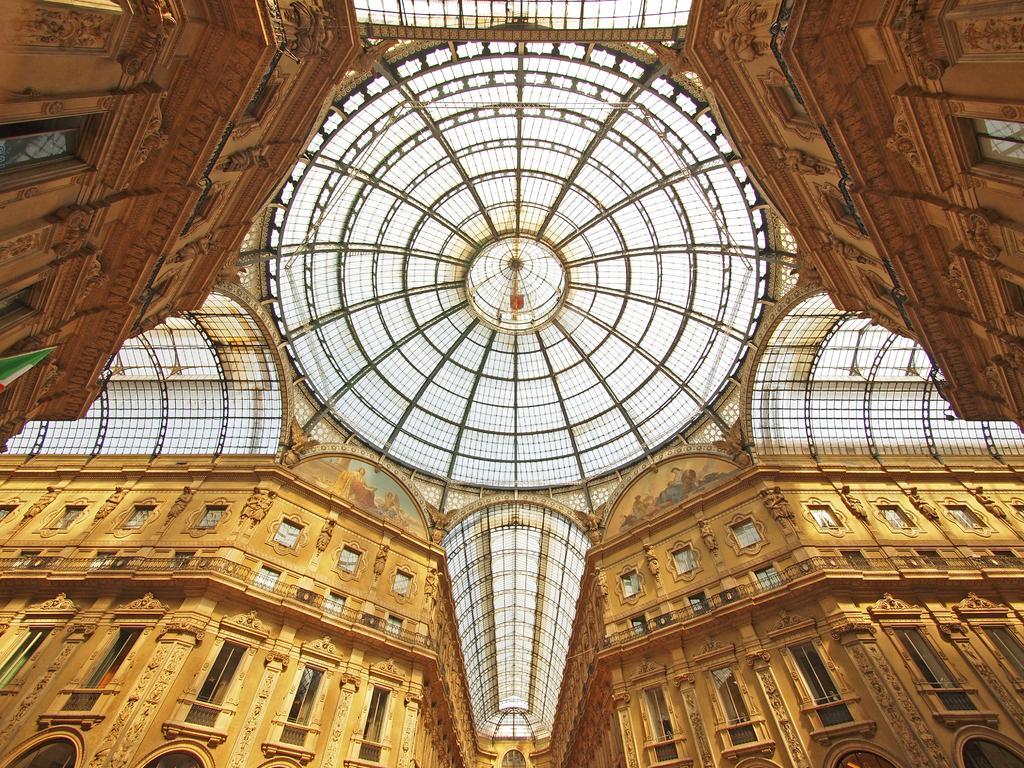Can you describe this image briefly? In this image we can see the roof. In the background of the image there are walls of the building. 